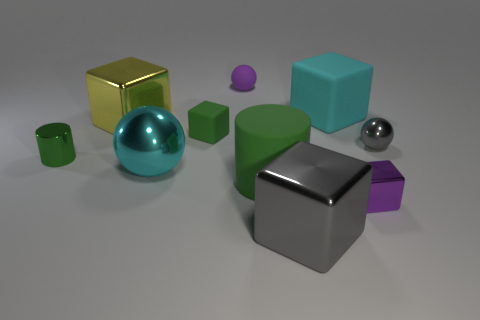Subtract all big cyan cubes. How many cubes are left? 4 Subtract all green cubes. How many cubes are left? 4 Subtract all cylinders. How many objects are left? 8 Subtract all blue cylinders. How many blue cubes are left? 0 Add 4 yellow objects. How many yellow objects are left? 5 Add 2 large red metal objects. How many large red metal objects exist? 2 Subtract 0 blue cylinders. How many objects are left? 10 Subtract 1 spheres. How many spheres are left? 2 Subtract all green blocks. Subtract all blue spheres. How many blocks are left? 4 Subtract all large yellow metallic cubes. Subtract all small green shiny things. How many objects are left? 8 